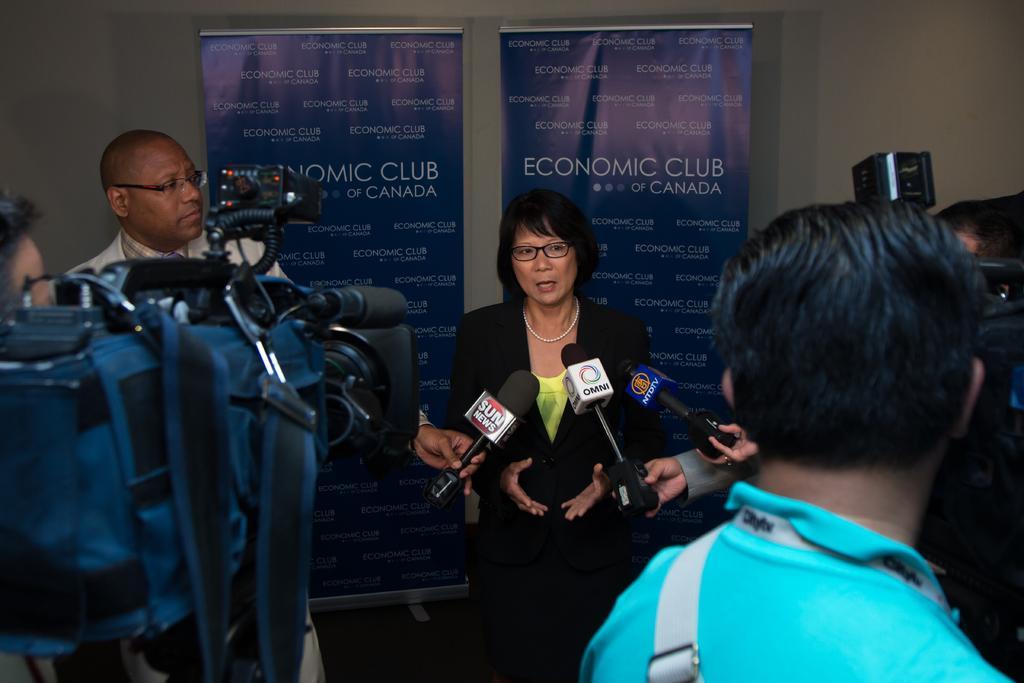How would you summarize this image in a sentence or two? In this image there is a woman standing in the center giving a speech. In front of the women there are mics. In the front on the left side there is a camera, on the right side there is a person standing. In the background there are banners with some text written on it and on the right side there is a camera and the person holding a camera. 